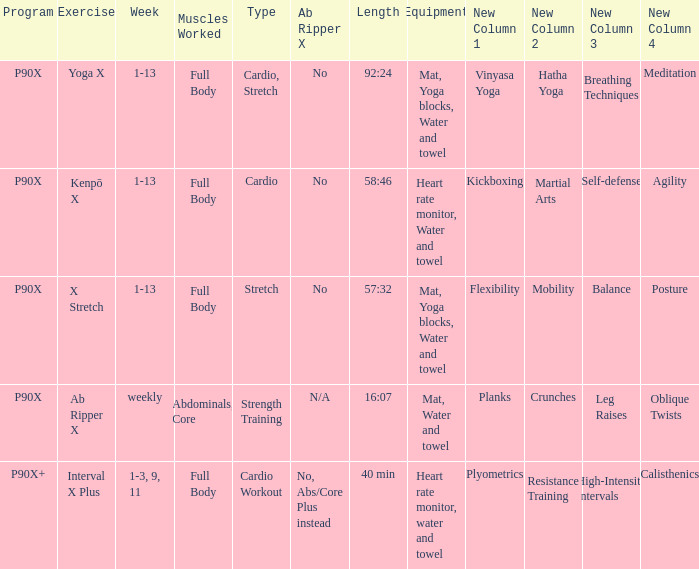How many types are cardio? 1.0. 